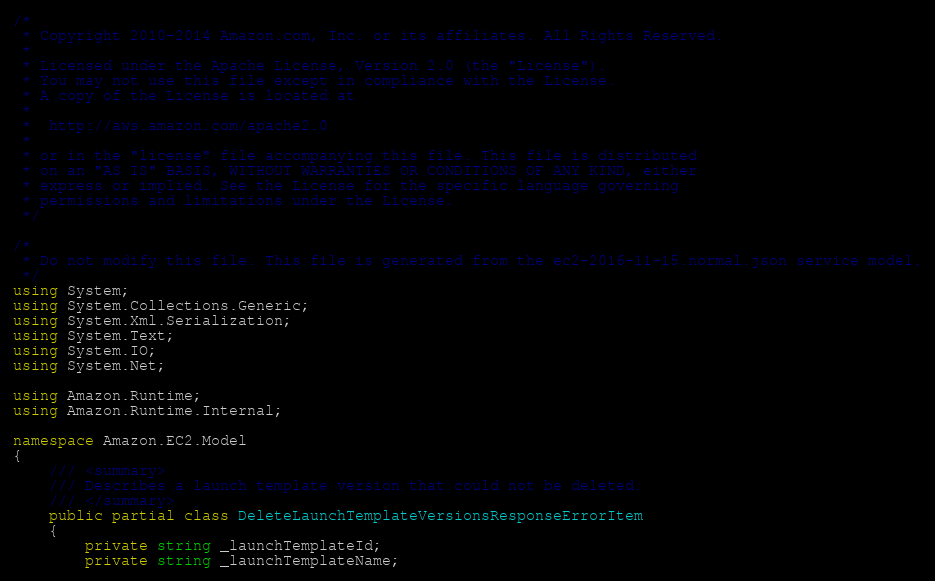Convert code to text. <code><loc_0><loc_0><loc_500><loc_500><_C#_>/*
 * Copyright 2010-2014 Amazon.com, Inc. or its affiliates. All Rights Reserved.
 * 
 * Licensed under the Apache License, Version 2.0 (the "License").
 * You may not use this file except in compliance with the License.
 * A copy of the License is located at
 * 
 *  http://aws.amazon.com/apache2.0
 * 
 * or in the "license" file accompanying this file. This file is distributed
 * on an "AS IS" BASIS, WITHOUT WARRANTIES OR CONDITIONS OF ANY KIND, either
 * express or implied. See the License for the specific language governing
 * permissions and limitations under the License.
 */

/*
 * Do not modify this file. This file is generated from the ec2-2016-11-15.normal.json service model.
 */
using System;
using System.Collections.Generic;
using System.Xml.Serialization;
using System.Text;
using System.IO;
using System.Net;

using Amazon.Runtime;
using Amazon.Runtime.Internal;

namespace Amazon.EC2.Model
{
    /// <summary>
    /// Describes a launch template version that could not be deleted.
    /// </summary>
    public partial class DeleteLaunchTemplateVersionsResponseErrorItem
    {
        private string _launchTemplateId;
        private string _launchTemplateName;</code> 